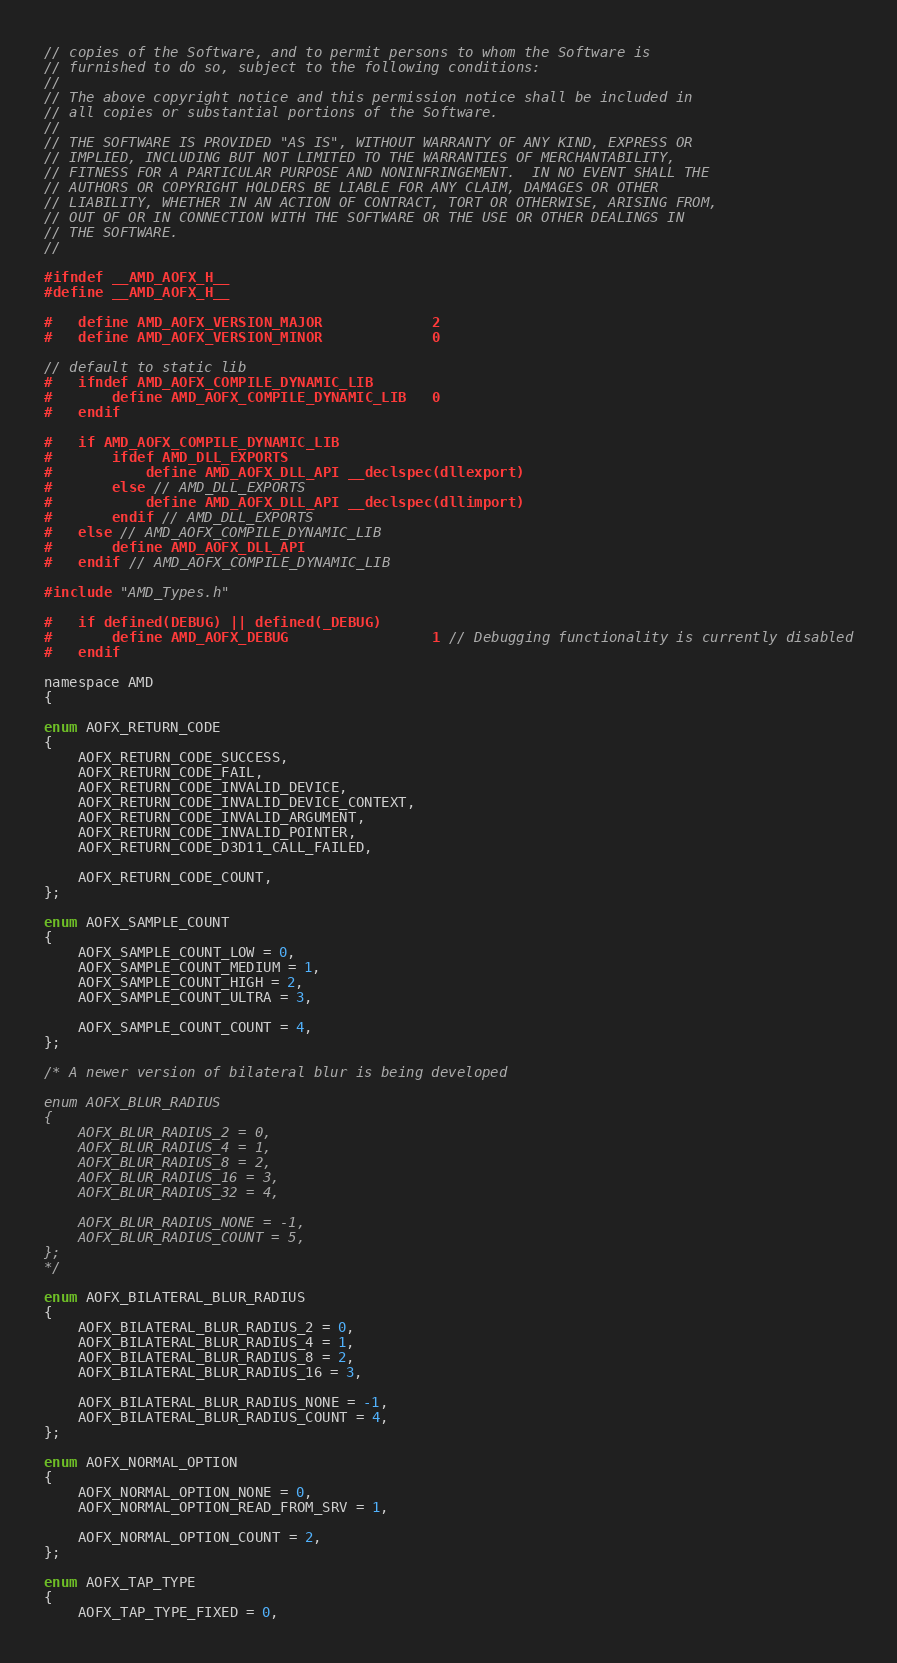Convert code to text. <code><loc_0><loc_0><loc_500><loc_500><_C_>// copies of the Software, and to permit persons to whom the Software is
// furnished to do so, subject to the following conditions:
//
// The above copyright notice and this permission notice shall be included in
// all copies or substantial portions of the Software.
//
// THE SOFTWARE IS PROVIDED "AS IS", WITHOUT WARRANTY OF ANY KIND, EXPRESS OR
// IMPLIED, INCLUDING BUT NOT LIMITED TO THE WARRANTIES OF MERCHANTABILITY,
// FITNESS FOR A PARTICULAR PURPOSE AND NONINFRINGEMENT.  IN NO EVENT SHALL THE
// AUTHORS OR COPYRIGHT HOLDERS BE LIABLE FOR ANY CLAIM, DAMAGES OR OTHER
// LIABILITY, WHETHER IN AN ACTION OF CONTRACT, TORT OR OTHERWISE, ARISING FROM,
// OUT OF OR IN CONNECTION WITH THE SOFTWARE OR THE USE OR OTHER DEALINGS IN
// THE SOFTWARE.
//

#ifndef __AMD_AOFX_H__
#define __AMD_AOFX_H__

#   define AMD_AOFX_VERSION_MAJOR             2
#   define AMD_AOFX_VERSION_MINOR             0

// default to static lib
#   ifndef AMD_AOFX_COMPILE_DYNAMIC_LIB
#       define AMD_AOFX_COMPILE_DYNAMIC_LIB   0
#   endif

#   if AMD_AOFX_COMPILE_DYNAMIC_LIB
#       ifdef AMD_DLL_EXPORTS
#           define AMD_AOFX_DLL_API __declspec(dllexport)
#       else // AMD_DLL_EXPORTS
#           define AMD_AOFX_DLL_API __declspec(dllimport)
#       endif // AMD_DLL_EXPORTS
#   else // AMD_AOFX_COMPILE_DYNAMIC_LIB
#       define AMD_AOFX_DLL_API
#   endif // AMD_AOFX_COMPILE_DYNAMIC_LIB

#include "AMD_Types.h"

#   if defined(DEBUG) || defined(_DEBUG)
#       define AMD_AOFX_DEBUG                 1 // Debugging functionality is currently disabled
#   endif

namespace AMD
{

enum AOFX_RETURN_CODE
{
    AOFX_RETURN_CODE_SUCCESS,
    AOFX_RETURN_CODE_FAIL,
    AOFX_RETURN_CODE_INVALID_DEVICE,
    AOFX_RETURN_CODE_INVALID_DEVICE_CONTEXT,
    AOFX_RETURN_CODE_INVALID_ARGUMENT,
    AOFX_RETURN_CODE_INVALID_POINTER,
    AOFX_RETURN_CODE_D3D11_CALL_FAILED,

    AOFX_RETURN_CODE_COUNT,
};

enum AOFX_SAMPLE_COUNT
{
    AOFX_SAMPLE_COUNT_LOW = 0,
    AOFX_SAMPLE_COUNT_MEDIUM = 1,
    AOFX_SAMPLE_COUNT_HIGH = 2,
    AOFX_SAMPLE_COUNT_ULTRA = 3,

    AOFX_SAMPLE_COUNT_COUNT = 4,
};

/* A newer version of bilateral blur is being developed

enum AOFX_BLUR_RADIUS
{
    AOFX_BLUR_RADIUS_2 = 0,
    AOFX_BLUR_RADIUS_4 = 1,
    AOFX_BLUR_RADIUS_8 = 2,
    AOFX_BLUR_RADIUS_16 = 3,
    AOFX_BLUR_RADIUS_32 = 4,

    AOFX_BLUR_RADIUS_NONE = -1,
    AOFX_BLUR_RADIUS_COUNT = 5,
};
*/ 

enum AOFX_BILATERAL_BLUR_RADIUS
{
    AOFX_BILATERAL_BLUR_RADIUS_2 = 0,
    AOFX_BILATERAL_BLUR_RADIUS_4 = 1,
    AOFX_BILATERAL_BLUR_RADIUS_8 = 2,
    AOFX_BILATERAL_BLUR_RADIUS_16 = 3,

    AOFX_BILATERAL_BLUR_RADIUS_NONE = -1,
    AOFX_BILATERAL_BLUR_RADIUS_COUNT = 4,
};

enum AOFX_NORMAL_OPTION
{
    AOFX_NORMAL_OPTION_NONE = 0,
    AOFX_NORMAL_OPTION_READ_FROM_SRV = 1,

    AOFX_NORMAL_OPTION_COUNT = 2,
};

enum AOFX_TAP_TYPE
{
    AOFX_TAP_TYPE_FIXED = 0,</code> 